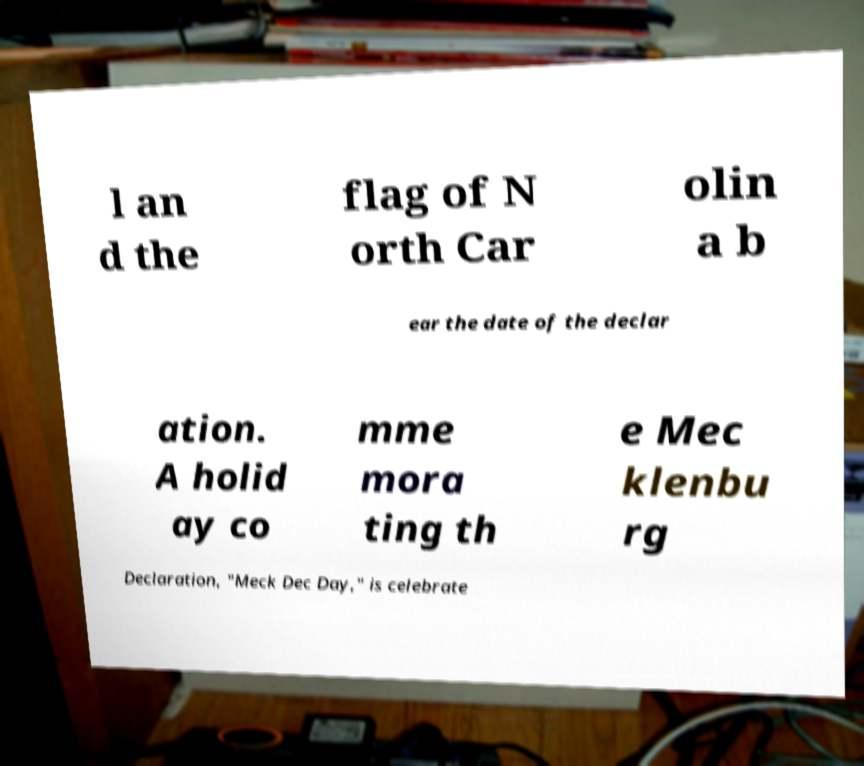Please read and relay the text visible in this image. What does it say? l an d the flag of N orth Car olin a b ear the date of the declar ation. A holid ay co mme mora ting th e Mec klenbu rg Declaration, "Meck Dec Day," is celebrate 